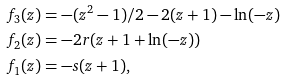<formula> <loc_0><loc_0><loc_500><loc_500>f _ { 3 } ( z ) & = - ( z ^ { 2 } - 1 ) / 2 - 2 ( z + 1 ) - \ln ( - z ) \\ f _ { 2 } ( z ) & = - 2 r ( z + 1 + \ln ( - z ) ) \\ f _ { 1 } ( z ) & = - s ( z + 1 ) ,</formula> 